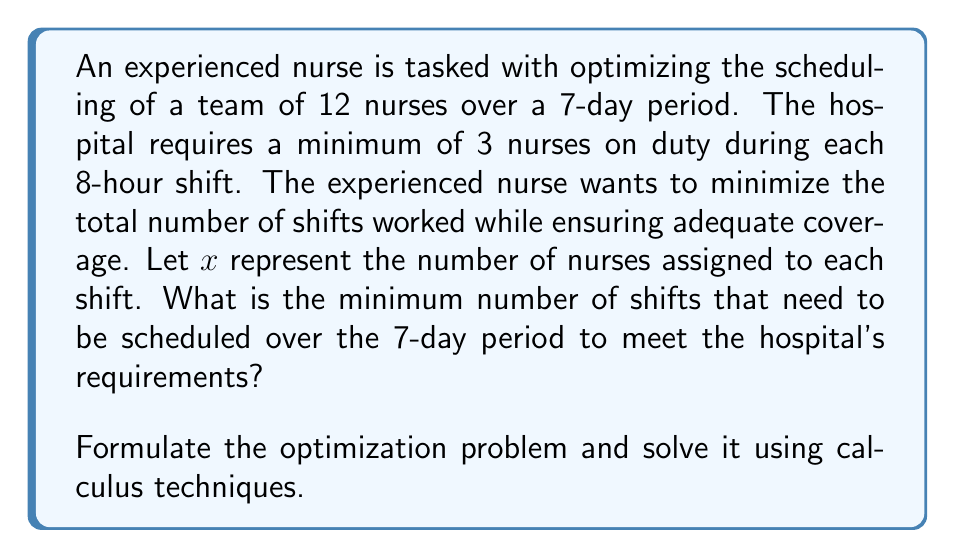Show me your answer to this math problem. Let's approach this problem step-by-step:

1) First, we need to set up our objective function and constraints:

   Objective function: Minimize the total number of shifts
   $f(x) = 21x$ (3 shifts per day * 7 days * x nurses per shift)

   Constraint: $x \geq 3$ (at least 3 nurses per shift)

2) To ensure we have enough nurses for all shifts, we need:
   $21x \leq 12 * 7 = 84$ (12 nurses * 7 days)

3) Our optimization problem becomes:
   Minimize $f(x) = 21x$
   Subject to: $3 \leq x \leq 4$ (since $x = 4$ is the largest value that satisfies $21x \leq 84$)

4) Since we're minimizing a linear function over a closed interval, the minimum will occur at one of the endpoints. We need to evaluate $f(x)$ at $x = 3$ and $x = 4$:

   $f(3) = 21 * 3 = 63$
   $f(4) = 21 * 4 = 84$

5) The minimum value occurs at $x = 3$, which means we should schedule 3 nurses per shift.

6) The total number of shifts over the 7-day period is therefore:
   $21 * 3 = 63$ shifts

This solution ensures that we have the minimum number of 3 nurses on each shift, meeting the hospital's requirements while minimizing the total number of shifts worked.
Answer: The minimum number of shifts that need to be scheduled over the 7-day period is 63. 